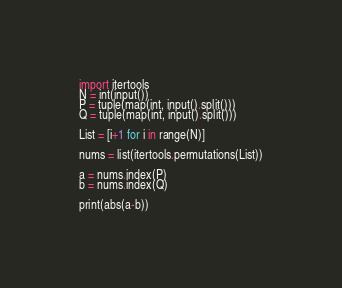Convert code to text. <code><loc_0><loc_0><loc_500><loc_500><_Python_>import itertools
N = int(input())
P = tuple(map(int, input().split()))
Q = tuple(map(int, input().split()))

List = [i+1 for i in range(N)]

nums = list(itertools.permutations(List))

a = nums.index(P)
b = nums.index(Q)

print(abs(a-b))</code> 